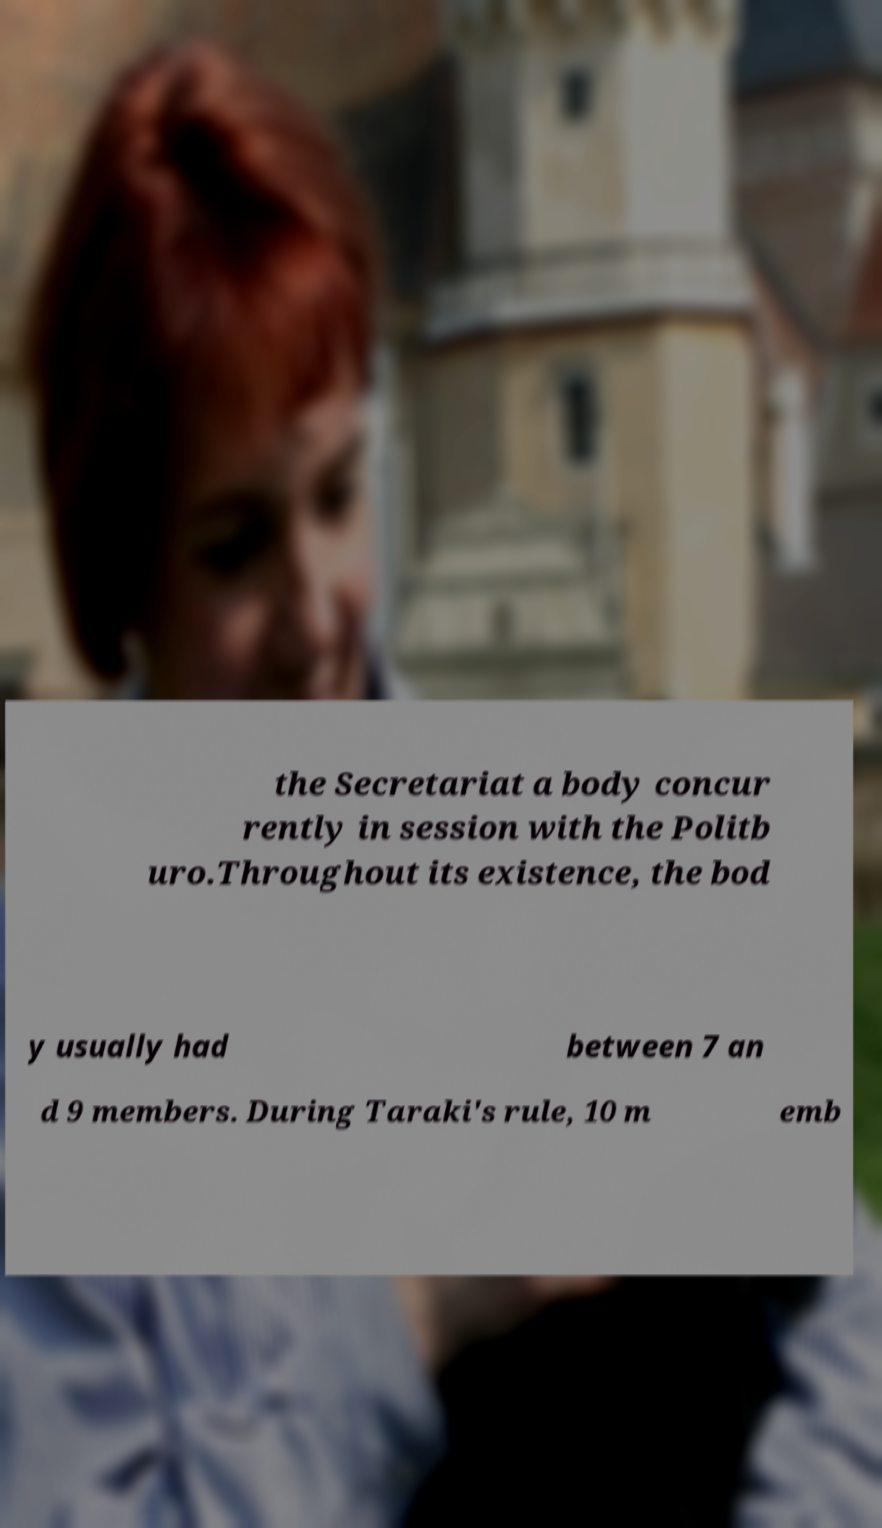There's text embedded in this image that I need extracted. Can you transcribe it verbatim? the Secretariat a body concur rently in session with the Politb uro.Throughout its existence, the bod y usually had between 7 an d 9 members. During Taraki's rule, 10 m emb 